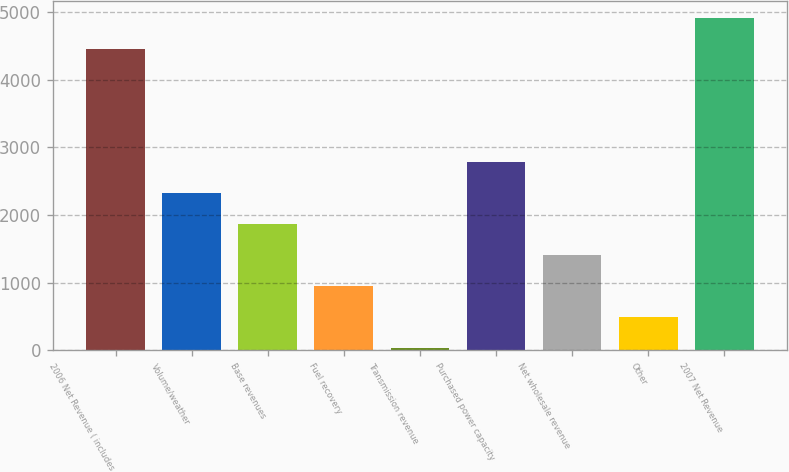Convert chart to OTSL. <chart><loc_0><loc_0><loc_500><loc_500><bar_chart><fcel>2006 Net Revenue ( includes<fcel>Volume/weather<fcel>Base revenues<fcel>Fuel recovery<fcel>Transmission revenue<fcel>Purchased power capacity<fcel>Net wholesale revenue<fcel>Other<fcel>2007 Net Revenue<nl><fcel>4458.1<fcel>2328.1<fcel>1870.16<fcel>954.28<fcel>38.4<fcel>2786.04<fcel>1412.22<fcel>496.34<fcel>4916.04<nl></chart> 